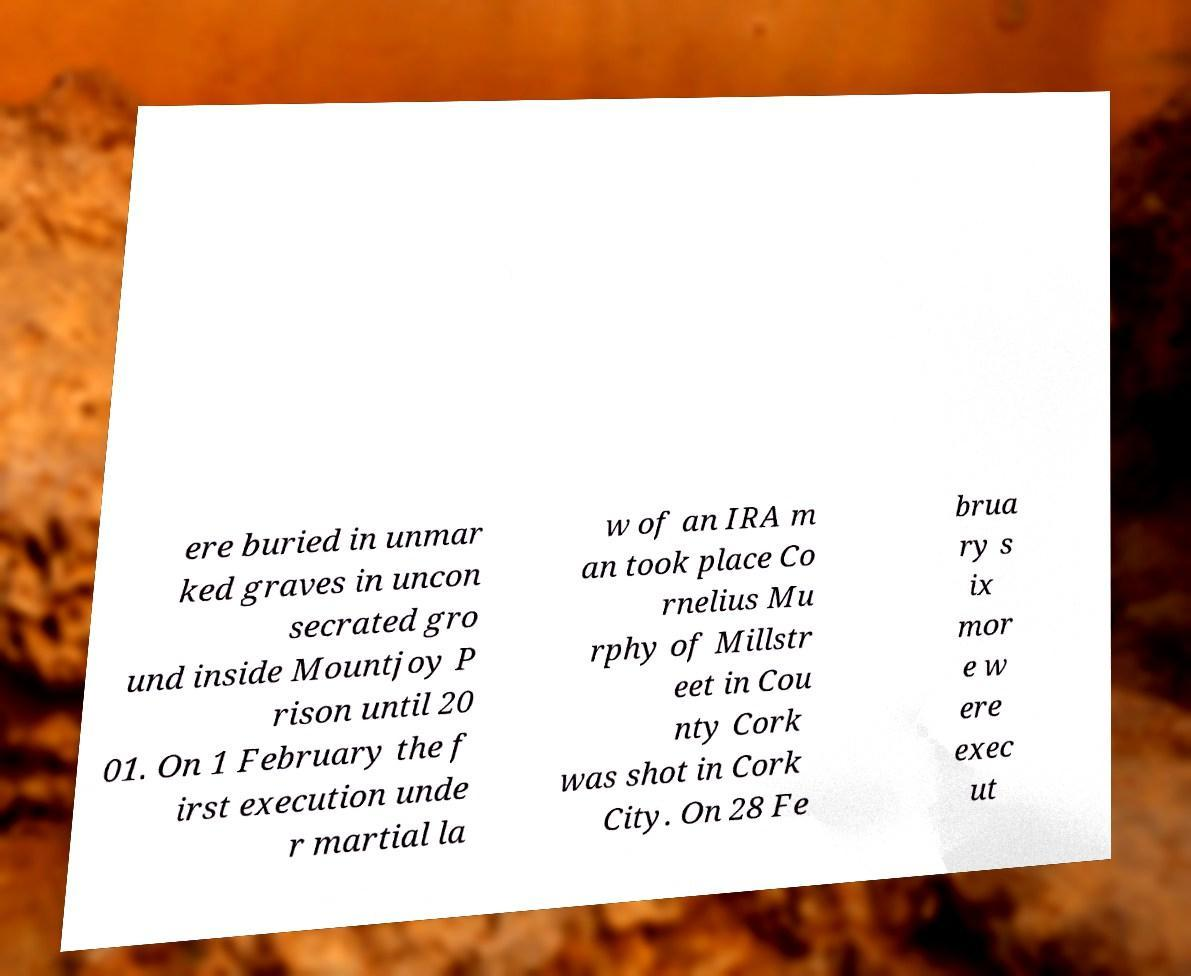Can you read and provide the text displayed in the image?This photo seems to have some interesting text. Can you extract and type it out for me? ere buried in unmar ked graves in uncon secrated gro und inside Mountjoy P rison until 20 01. On 1 February the f irst execution unde r martial la w of an IRA m an took place Co rnelius Mu rphy of Millstr eet in Cou nty Cork was shot in Cork City. On 28 Fe brua ry s ix mor e w ere exec ut 